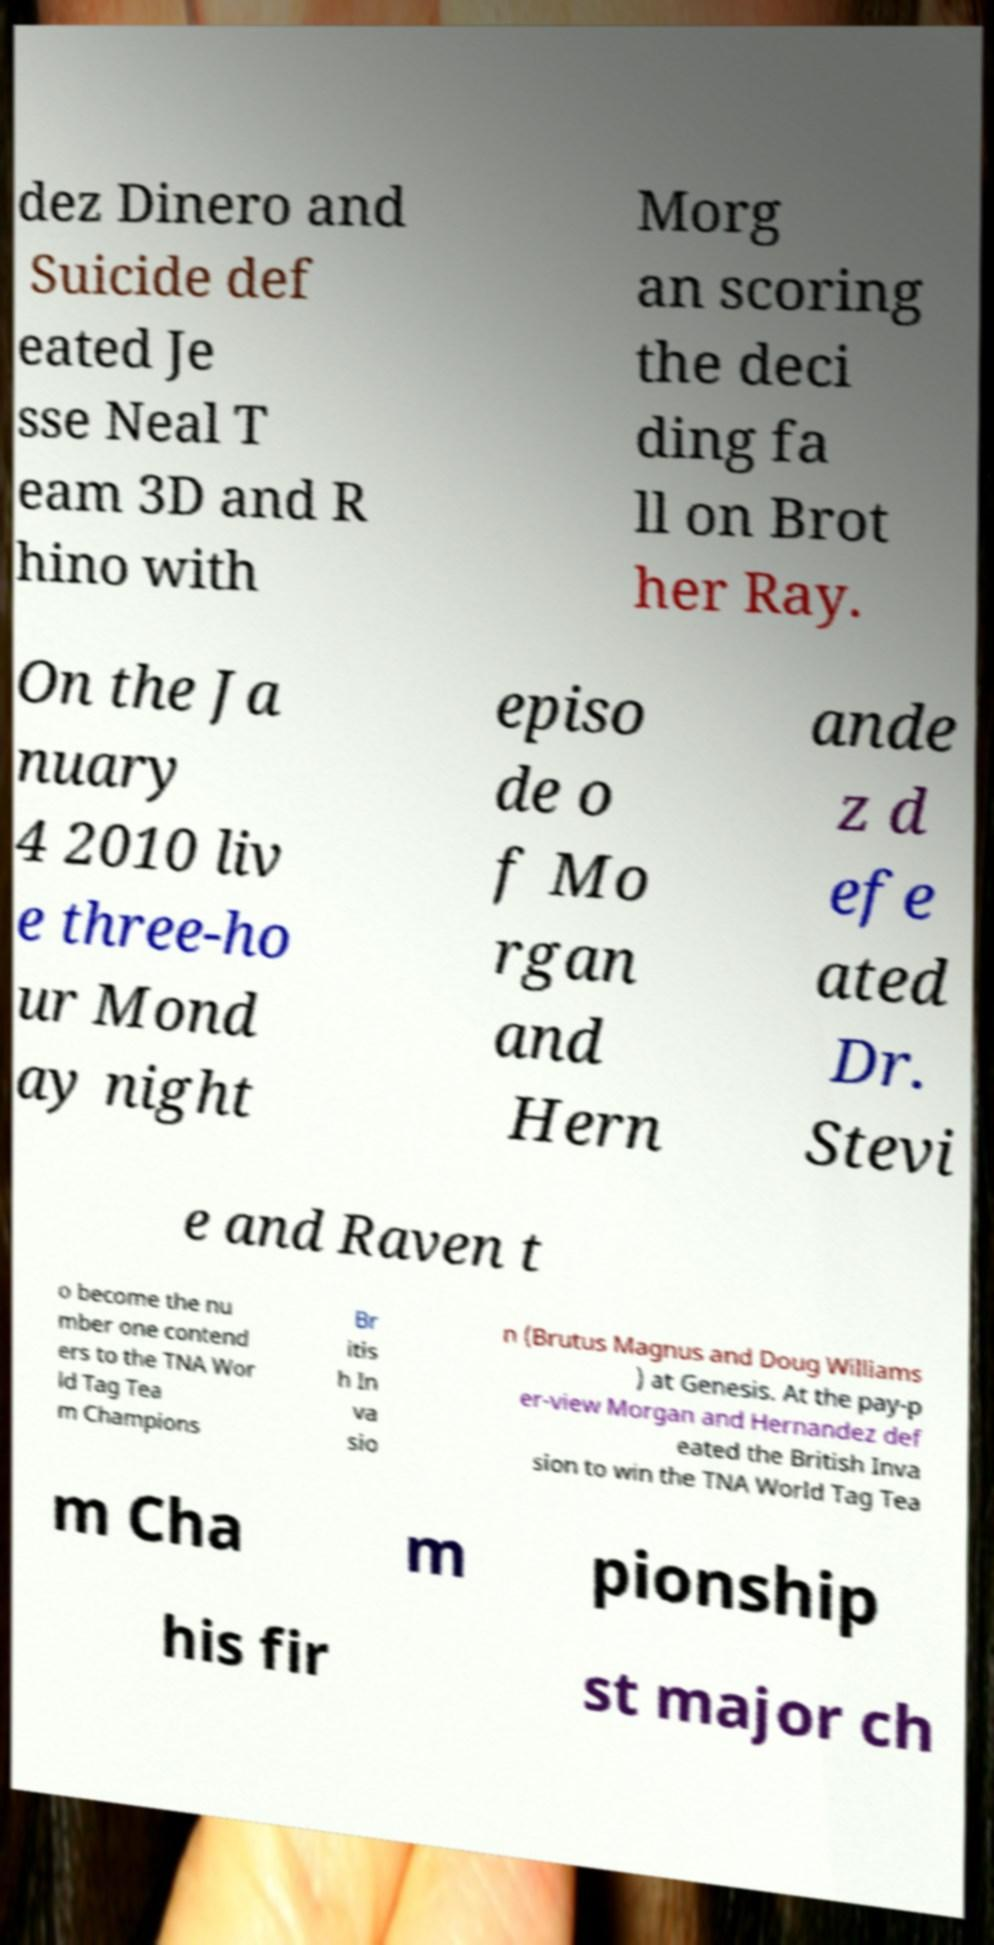Can you accurately transcribe the text from the provided image for me? dez Dinero and Suicide def eated Je sse Neal T eam 3D and R hino with Morg an scoring the deci ding fa ll on Brot her Ray. On the Ja nuary 4 2010 liv e three-ho ur Mond ay night episo de o f Mo rgan and Hern ande z d efe ated Dr. Stevi e and Raven t o become the nu mber one contend ers to the TNA Wor ld Tag Tea m Champions Br itis h In va sio n (Brutus Magnus and Doug Williams ) at Genesis. At the pay-p er-view Morgan and Hernandez def eated the British Inva sion to win the TNA World Tag Tea m Cha m pionship his fir st major ch 